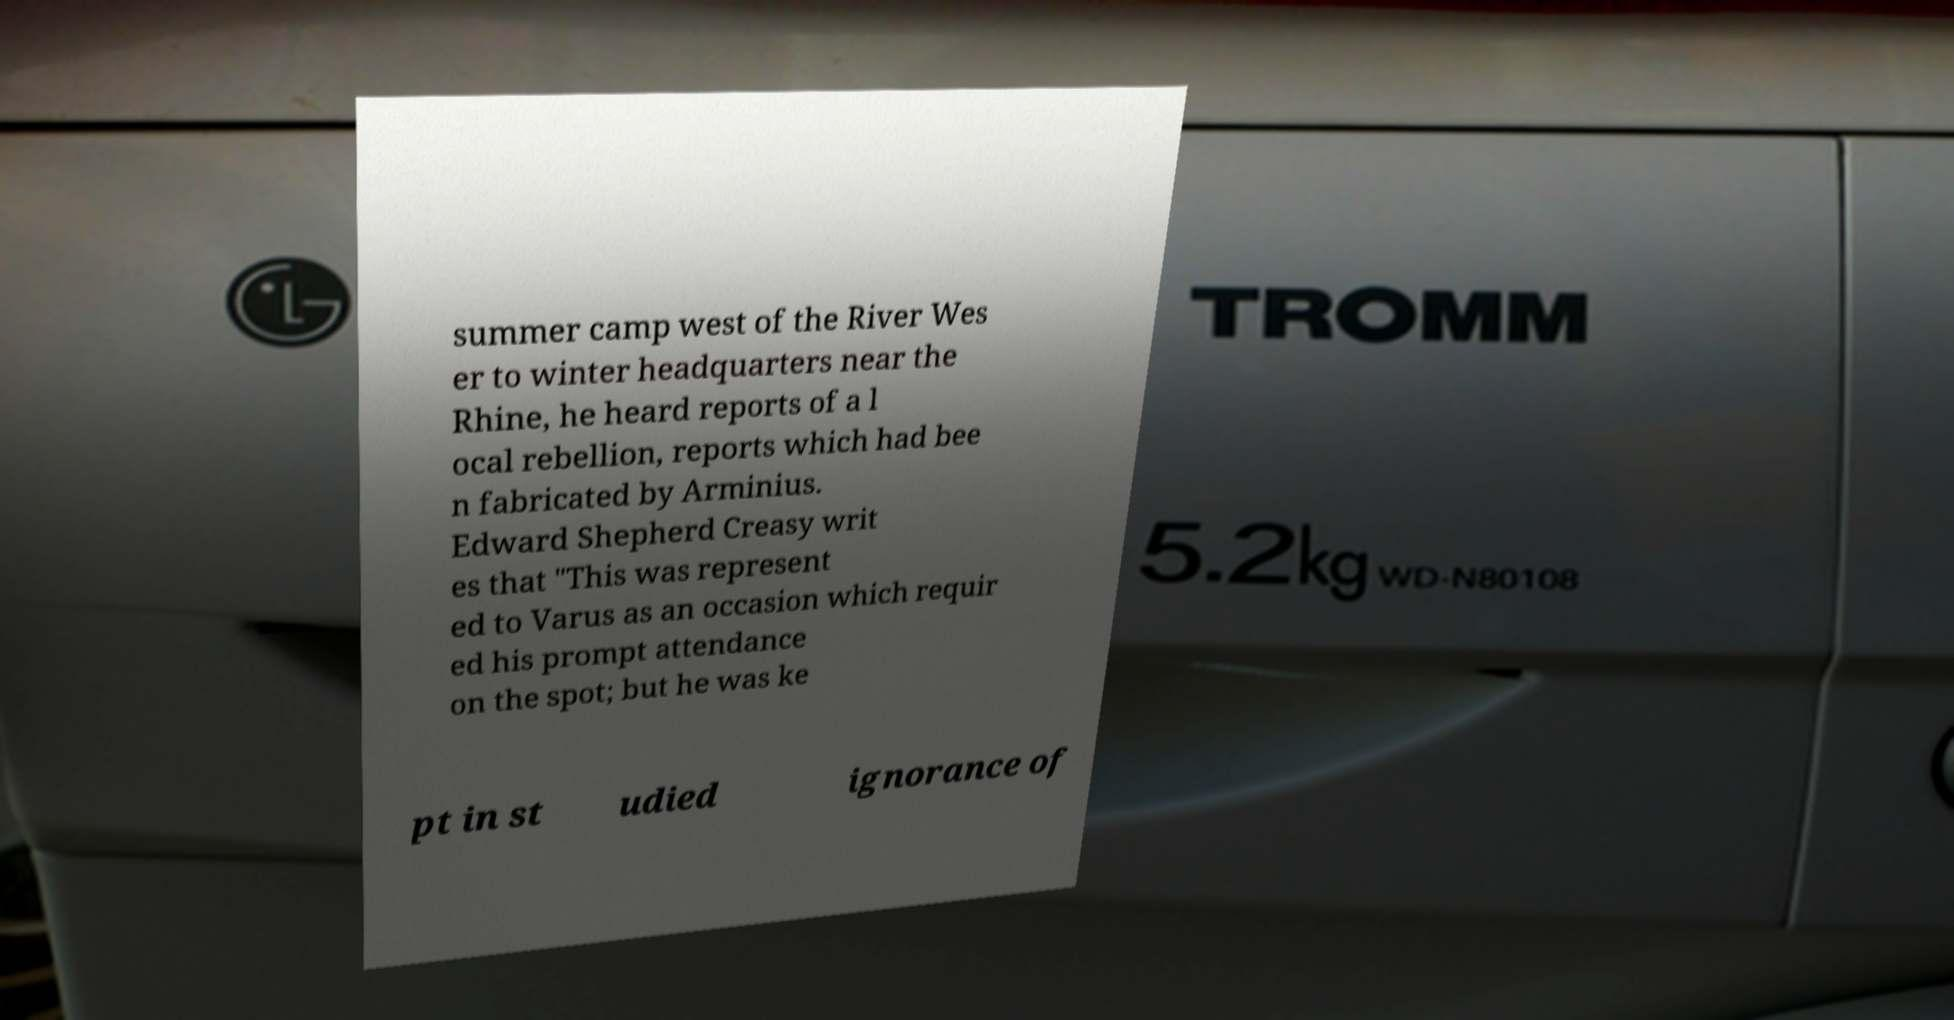There's text embedded in this image that I need extracted. Can you transcribe it verbatim? summer camp west of the River Wes er to winter headquarters near the Rhine, he heard reports of a l ocal rebellion, reports which had bee n fabricated by Arminius. Edward Shepherd Creasy writ es that "This was represent ed to Varus as an occasion which requir ed his prompt attendance on the spot; but he was ke pt in st udied ignorance of 